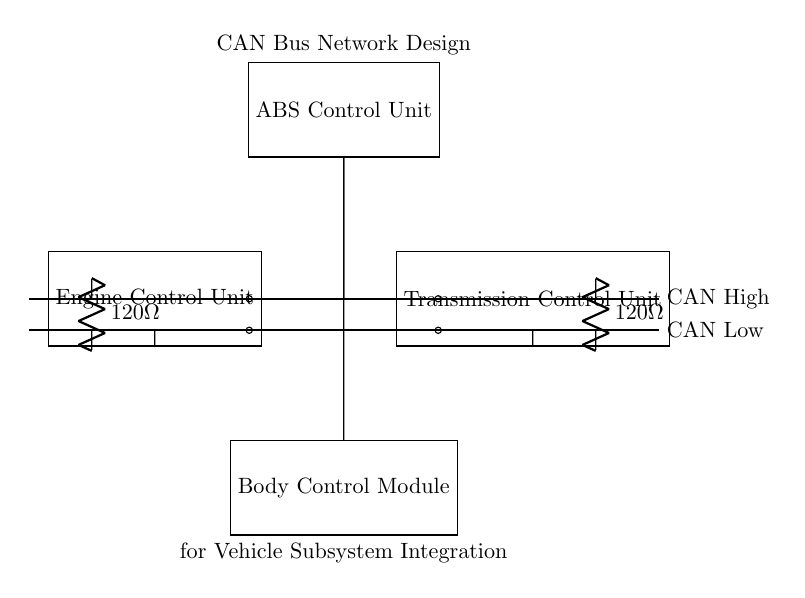What components are included in the circuit? The diagram shows four main components: the Engine Control Unit, Transmission Control Unit, ABS Control Unit, and Body Control Module.
Answer: Engine Control Unit, Transmission Control Unit, ABS Control Unit, Body Control Module What is the purpose of the resistors in the circuit? The resistors have a value of 120 Ohms and are used as termination resistors for the CAN Bus network, ensuring signal integrity by reducing reflections.
Answer: Termination resistors How many modules are connected to the CAN Bus? The circuit diagram shows a total of four modules connected to the CAN Bus, which are the ECU, TCU, ABS, and BCM.
Answer: Four What is the name of the communication protocol used in the circuit? The communication protocol used in this circuit is the CAN Bus, which stands for Controller Area Network, designed for vehicle subsystems communication.
Answer: CAN Bus Which unit is positioned above the CAN Bus in the diagram? The ABS Control Unit is positioned above the CAN Bus, as indicated in the layout of the circuit diagram.
Answer: ABS Control Unit How do the modules connect to the CAN High and CAN Low lines? Each module connects directly to the CAN High and CAN Low lines through individual wires, allowing them to communicate over the network.
Answer: Direct connections What is the significance of the bus lines in the circuit? The CAN High and CAN Low lines form the backbone of the communication network, facilitating data transmission between multiple vehicle subsystems efficiently.
Answer: Backbone of communication 